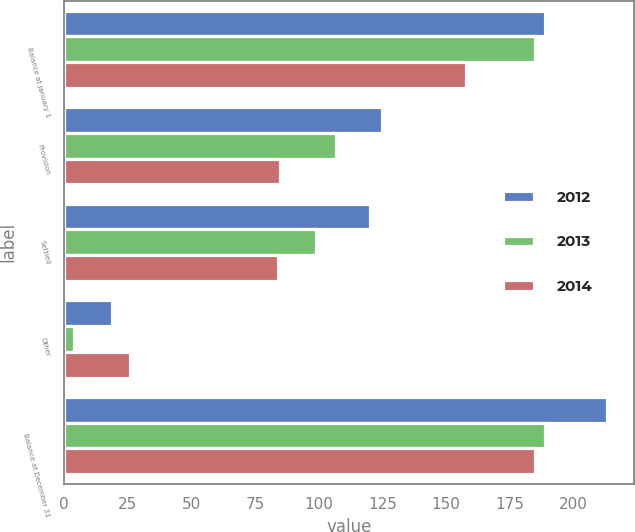Convert chart. <chart><loc_0><loc_0><loc_500><loc_500><stacked_bar_chart><ecel><fcel>Balance at January 1<fcel>Provision<fcel>Settled<fcel>Other<fcel>Balance at December 31<nl><fcel>2012<fcel>189<fcel>125<fcel>120<fcel>19<fcel>213<nl><fcel>2013<fcel>185<fcel>107<fcel>99<fcel>4<fcel>189<nl><fcel>2014<fcel>158<fcel>85<fcel>84<fcel>26<fcel>185<nl></chart> 